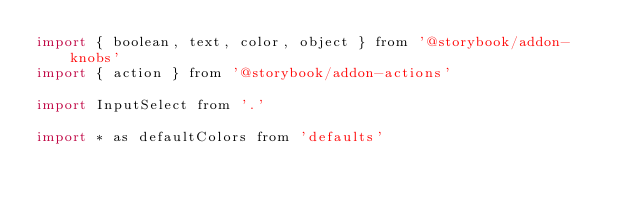<code> <loc_0><loc_0><loc_500><loc_500><_JavaScript_>import { boolean, text, color, object } from '@storybook/addon-knobs'
import { action } from '@storybook/addon-actions'

import InputSelect from '.'

import * as defaultColors from 'defaults'
</code> 